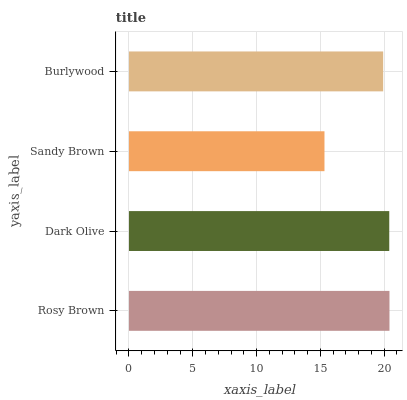Is Sandy Brown the minimum?
Answer yes or no. Yes. Is Rosy Brown the maximum?
Answer yes or no. Yes. Is Dark Olive the minimum?
Answer yes or no. No. Is Dark Olive the maximum?
Answer yes or no. No. Is Rosy Brown greater than Dark Olive?
Answer yes or no. Yes. Is Dark Olive less than Rosy Brown?
Answer yes or no. Yes. Is Dark Olive greater than Rosy Brown?
Answer yes or no. No. Is Rosy Brown less than Dark Olive?
Answer yes or no. No. Is Dark Olive the high median?
Answer yes or no. Yes. Is Burlywood the low median?
Answer yes or no. Yes. Is Rosy Brown the high median?
Answer yes or no. No. Is Rosy Brown the low median?
Answer yes or no. No. 